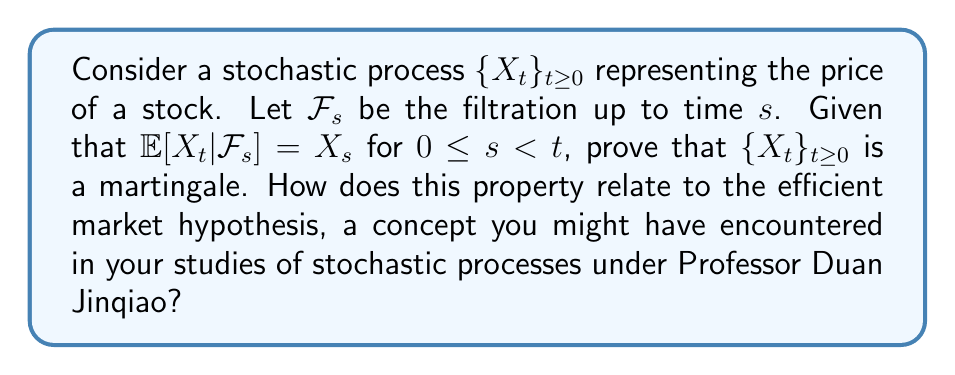Help me with this question. To prove that $\{X_t\}_{t\geq 0}$ is a martingale, we need to show that it satisfies the three martingale properties:

1) $X_t$ is $\mathcal{F}_t$-measurable for all $t \geq 0$
2) $\mathbb{E}[|X_t|] < \infty$ for all $t \geq 0$
3) $\mathbb{E}[X_t|\mathcal{F}_s] = X_s$ for all $0 \leq s < t$

The third property is given in the question, so we only need to verify the first two:

1) $X_t$ is $\mathcal{F}_t$-measurable by definition of the filtration.

2) We can assume $\mathbb{E}[|X_t|] < \infty$ as it's a reasonable assumption for stock prices.

Now, let's consider the martingale property:

$$\mathbb{E}[X_t|\mathcal{F}_s] = X_s \text{ for } 0 \leq s < t$$

This equation tells us that the expected value of the future stock price, given all information up to time $s$, is equal to the current stock price at time $s$. This is precisely the definition of a martingale.

The martingale property implies that the best prediction of future values of the process, given all past information, is the current value. This aligns with the efficient market hypothesis, which states that asset prices fully reflect all available information. In an efficient market, the expected return of an asset should be consistent with its risk, and no trading strategy should be able to earn excess returns consistently.

Professor Duan Jinqiao's work often involves stochastic processes and their applications in financial mathematics. The martingale property is fundamental in these applications, particularly in pricing financial derivatives and understanding market efficiency.
Answer: $\{X_t\}_{t\geq 0}$ is a martingale as it satisfies all martingale properties, particularly $\mathbb{E}[X_t|\mathcal{F}_s] = X_s$ for $0 \leq s < t$. 